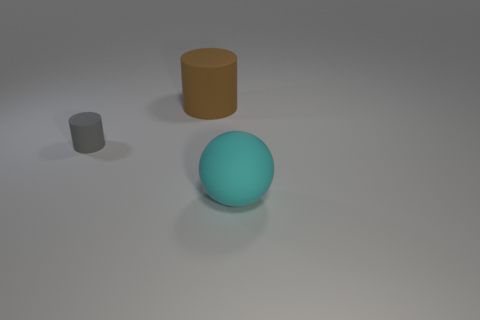Subtract all gray cylinders. Subtract all blue balls. How many cylinders are left? 1 Add 2 big shiny cylinders. How many objects exist? 5 Subtract all balls. How many objects are left? 2 Subtract 0 yellow cylinders. How many objects are left? 3 Subtract all balls. Subtract all gray matte things. How many objects are left? 1 Add 2 big cylinders. How many big cylinders are left? 3 Add 3 tiny gray rubber things. How many tiny gray rubber things exist? 4 